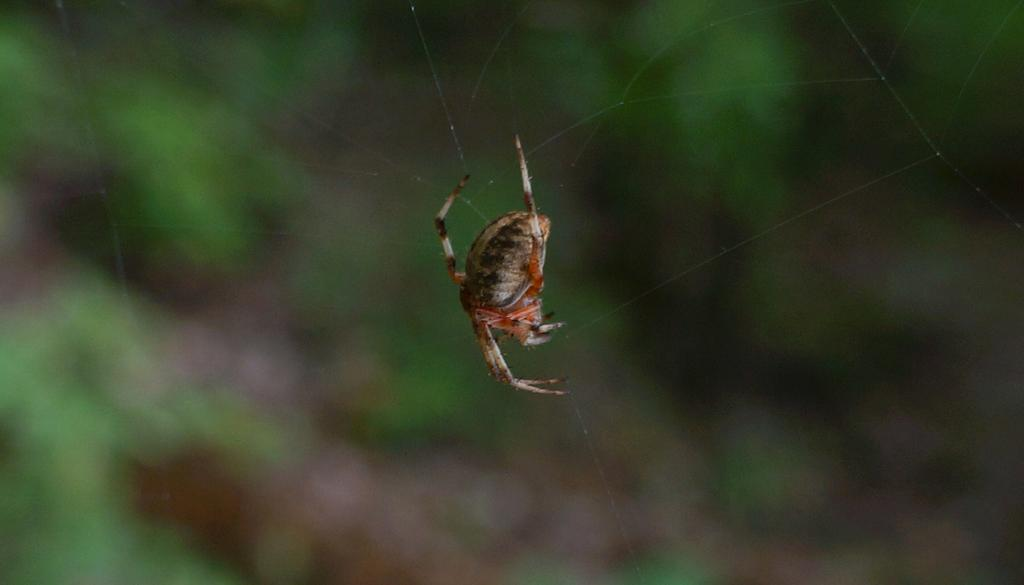What is the main subject of the image? There is a spider in the image. What is the spider associated with in the image? There is a web in the image. Can you describe the background of the image? The background of the image is blurred. What type of bean is being cooked on the throne in the image? There is no bean or throne present in the image; it features a spider and a web. How does the smoke from the bean affect the spider in the image? There is no smoke or bean present in the image, so it cannot affect the spider. 